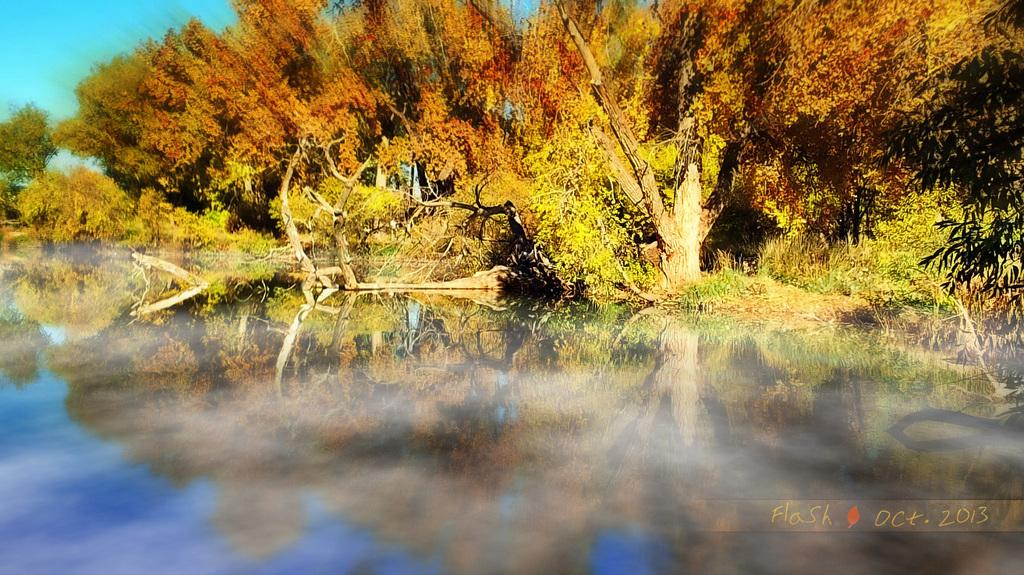What can be seen in the background of the image? There are trees in the background of the image. What else is present in the image besides the trees? There is text written on the image. What type of shoes is the minister wearing in the image? There is no minister or shoes present in the image; it only features trees in the background and text. 